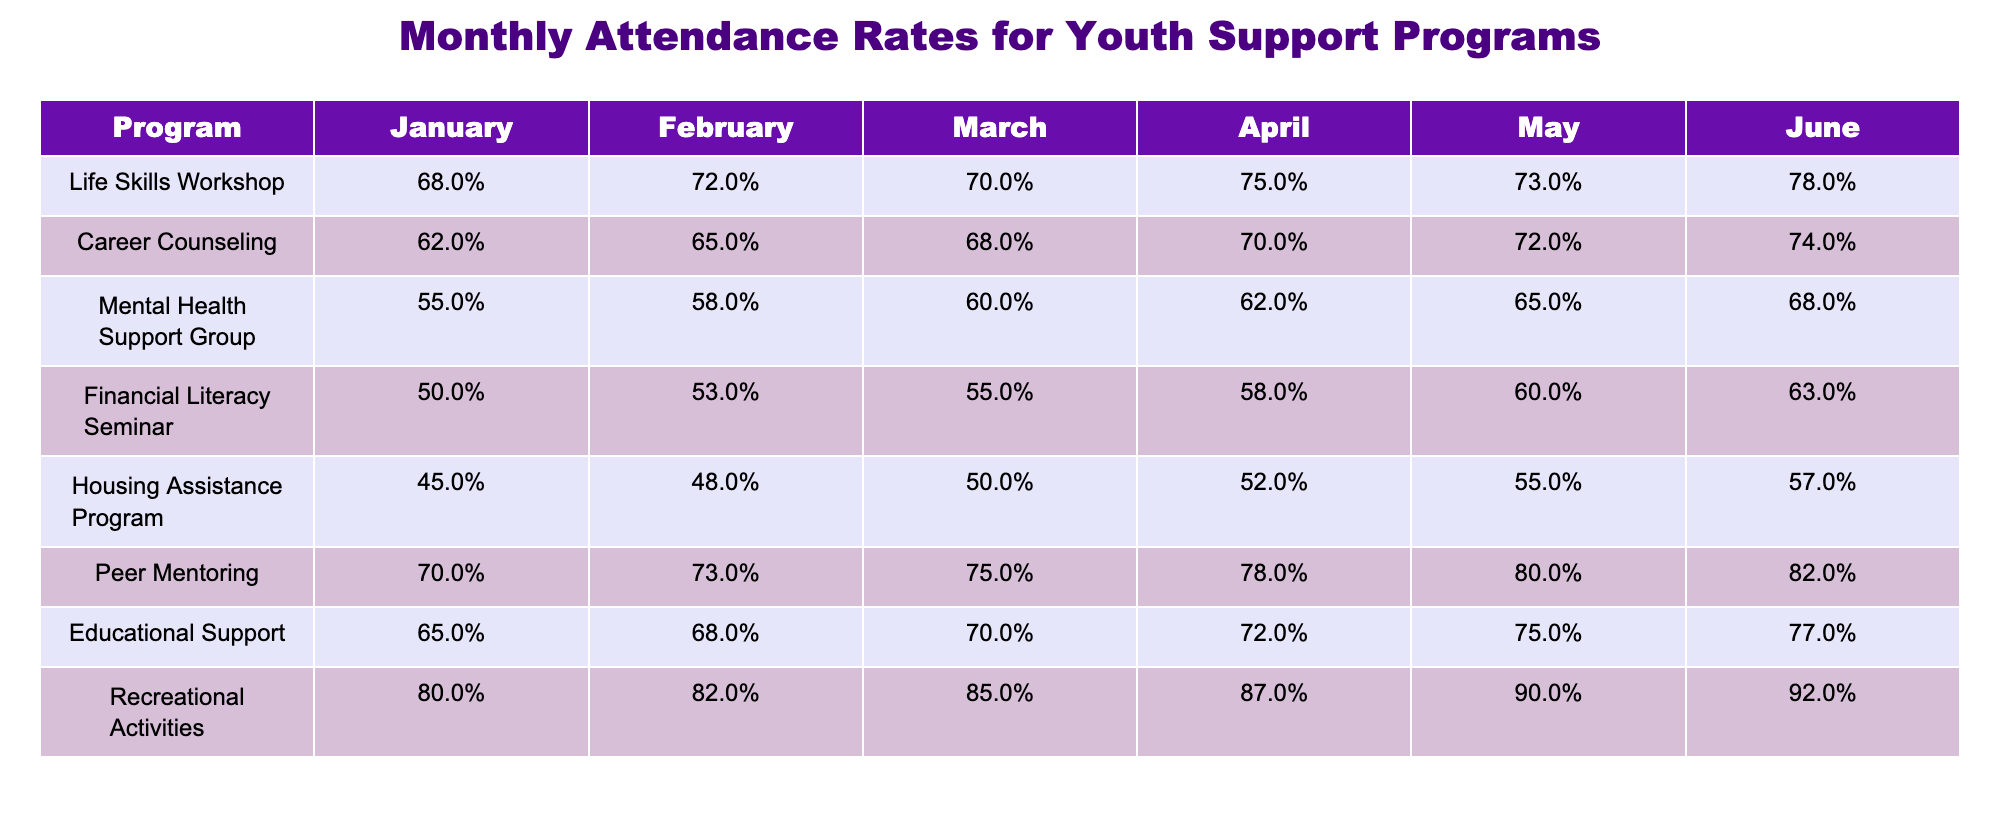What was the highest attendance rate in January among the programs? The highest attendance rate in January is found by comparing all the values in that column. The values are: Life Skills Workshop (68%), Career Counseling (62%), Mental Health Support Group (55%), Financial Literacy Seminar (50%), Housing Assistance Program (45%), Peer Mentoring (70%), Educational Support (65%), and Recreational Activities (80%). The highest value is 80% from Recreational Activities.
Answer: 80% What is the average attendance rate for the Mental Health Support Group for the first half of the year (January to June)? To find the average, we add the attendance rates from January to June (55%, 58%, 60%, 62%, 65%, 68%), which totals to 368%. We then divide by 6 (the number of months) to find the average: 368% / 6 = 61.33%.
Answer: 61.33% Did the Housing Assistance Program have an increase in attendance from January to June? To find this, we compare the attendance rates in January (45%) and June (57%). Since 57% is greater than 45%, it indicates an increase in attendance.
Answer: Yes Which program had the second highest attendance rate in May? In May, the attendance rates are: Life Skills Workshop (73%), Career Counseling (72%), Mental Health Support Group (65%), Financial Literacy Seminar (60%), Housing Assistance Program (55%), Peer Mentoring (80%), Educational Support (75%), and Recreational Activities (90%). The second highest is 80% from Peer Mentoring after Recreational Activities (90%).
Answer: Peer Mentoring How much higher is the attendance rate of the Recreational Activities program compared to the Financial Literacy Seminar in June? In June, the attendance rate for Recreational Activities is 92%, and for Financial Literacy Seminar is 63%. We find the difference by subtracting 63% from 92%, which equals 29%. Thus, Recreational Activities has a 29% higher attendance rate.
Answer: 29% 